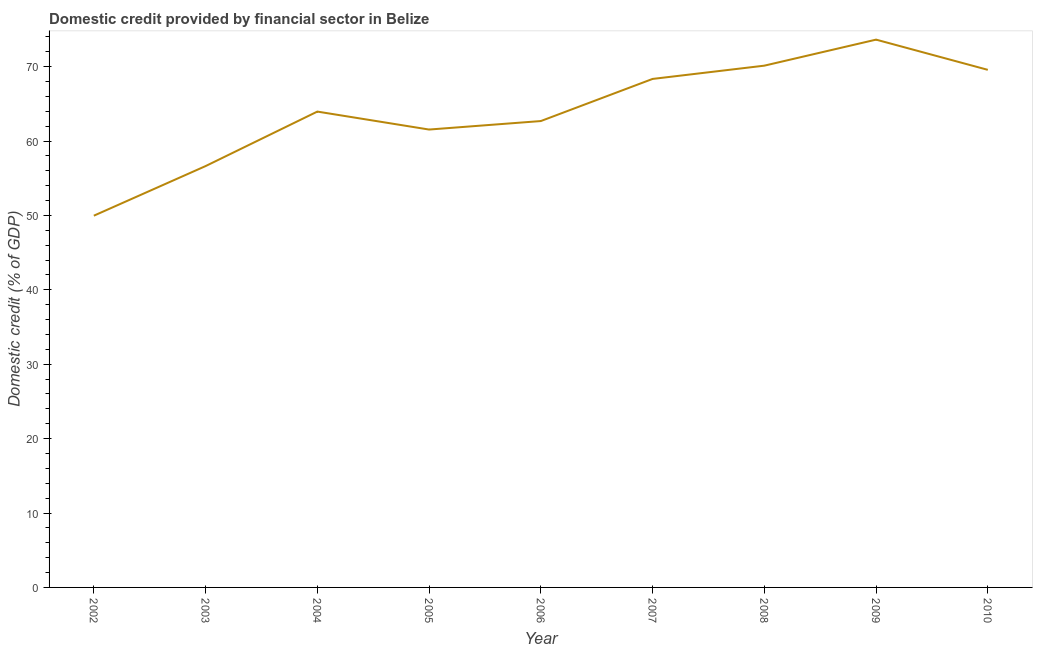What is the domestic credit provided by financial sector in 2002?
Your answer should be very brief. 49.97. Across all years, what is the maximum domestic credit provided by financial sector?
Give a very brief answer. 73.63. Across all years, what is the minimum domestic credit provided by financial sector?
Your answer should be compact. 49.97. In which year was the domestic credit provided by financial sector maximum?
Your answer should be compact. 2009. What is the sum of the domestic credit provided by financial sector?
Your answer should be very brief. 576.47. What is the difference between the domestic credit provided by financial sector in 2003 and 2009?
Give a very brief answer. -17. What is the average domestic credit provided by financial sector per year?
Your answer should be very brief. 64.05. What is the median domestic credit provided by financial sector?
Your answer should be compact. 63.96. Do a majority of the years between 2005 and 2002 (inclusive) have domestic credit provided by financial sector greater than 66 %?
Offer a very short reply. Yes. What is the ratio of the domestic credit provided by financial sector in 2006 to that in 2010?
Your answer should be compact. 0.9. What is the difference between the highest and the second highest domestic credit provided by financial sector?
Your response must be concise. 3.5. What is the difference between the highest and the lowest domestic credit provided by financial sector?
Make the answer very short. 23.67. How many years are there in the graph?
Provide a short and direct response. 9. What is the difference between two consecutive major ticks on the Y-axis?
Make the answer very short. 10. Does the graph contain any zero values?
Your answer should be compact. No. Does the graph contain grids?
Your response must be concise. No. What is the title of the graph?
Offer a terse response. Domestic credit provided by financial sector in Belize. What is the label or title of the Y-axis?
Offer a terse response. Domestic credit (% of GDP). What is the Domestic credit (% of GDP) in 2002?
Make the answer very short. 49.97. What is the Domestic credit (% of GDP) of 2003?
Provide a short and direct response. 56.63. What is the Domestic credit (% of GDP) of 2004?
Ensure brevity in your answer.  63.96. What is the Domestic credit (% of GDP) in 2005?
Ensure brevity in your answer.  61.55. What is the Domestic credit (% of GDP) in 2006?
Keep it short and to the point. 62.69. What is the Domestic credit (% of GDP) in 2007?
Ensure brevity in your answer.  68.35. What is the Domestic credit (% of GDP) of 2008?
Your answer should be very brief. 70.13. What is the Domestic credit (% of GDP) of 2009?
Give a very brief answer. 73.63. What is the Domestic credit (% of GDP) of 2010?
Your answer should be very brief. 69.57. What is the difference between the Domestic credit (% of GDP) in 2002 and 2003?
Ensure brevity in your answer.  -6.67. What is the difference between the Domestic credit (% of GDP) in 2002 and 2004?
Your answer should be compact. -13.99. What is the difference between the Domestic credit (% of GDP) in 2002 and 2005?
Your answer should be compact. -11.58. What is the difference between the Domestic credit (% of GDP) in 2002 and 2006?
Keep it short and to the point. -12.72. What is the difference between the Domestic credit (% of GDP) in 2002 and 2007?
Provide a short and direct response. -18.38. What is the difference between the Domestic credit (% of GDP) in 2002 and 2008?
Ensure brevity in your answer.  -20.17. What is the difference between the Domestic credit (% of GDP) in 2002 and 2009?
Your response must be concise. -23.67. What is the difference between the Domestic credit (% of GDP) in 2002 and 2010?
Make the answer very short. -19.6. What is the difference between the Domestic credit (% of GDP) in 2003 and 2004?
Your response must be concise. -7.32. What is the difference between the Domestic credit (% of GDP) in 2003 and 2005?
Make the answer very short. -4.91. What is the difference between the Domestic credit (% of GDP) in 2003 and 2006?
Offer a very short reply. -6.05. What is the difference between the Domestic credit (% of GDP) in 2003 and 2007?
Offer a very short reply. -11.71. What is the difference between the Domestic credit (% of GDP) in 2003 and 2008?
Provide a short and direct response. -13.5. What is the difference between the Domestic credit (% of GDP) in 2003 and 2009?
Ensure brevity in your answer.  -17. What is the difference between the Domestic credit (% of GDP) in 2003 and 2010?
Your response must be concise. -12.94. What is the difference between the Domestic credit (% of GDP) in 2004 and 2005?
Your answer should be very brief. 2.41. What is the difference between the Domestic credit (% of GDP) in 2004 and 2006?
Make the answer very short. 1.27. What is the difference between the Domestic credit (% of GDP) in 2004 and 2007?
Provide a short and direct response. -4.39. What is the difference between the Domestic credit (% of GDP) in 2004 and 2008?
Keep it short and to the point. -6.17. What is the difference between the Domestic credit (% of GDP) in 2004 and 2009?
Ensure brevity in your answer.  -9.67. What is the difference between the Domestic credit (% of GDP) in 2004 and 2010?
Your answer should be very brief. -5.61. What is the difference between the Domestic credit (% of GDP) in 2005 and 2006?
Offer a terse response. -1.14. What is the difference between the Domestic credit (% of GDP) in 2005 and 2007?
Offer a terse response. -6.8. What is the difference between the Domestic credit (% of GDP) in 2005 and 2008?
Ensure brevity in your answer.  -8.59. What is the difference between the Domestic credit (% of GDP) in 2005 and 2009?
Provide a short and direct response. -12.09. What is the difference between the Domestic credit (% of GDP) in 2005 and 2010?
Offer a terse response. -8.03. What is the difference between the Domestic credit (% of GDP) in 2006 and 2007?
Provide a succinct answer. -5.66. What is the difference between the Domestic credit (% of GDP) in 2006 and 2008?
Offer a very short reply. -7.45. What is the difference between the Domestic credit (% of GDP) in 2006 and 2009?
Your answer should be very brief. -10.94. What is the difference between the Domestic credit (% of GDP) in 2006 and 2010?
Your answer should be very brief. -6.88. What is the difference between the Domestic credit (% of GDP) in 2007 and 2008?
Your answer should be compact. -1.78. What is the difference between the Domestic credit (% of GDP) in 2007 and 2009?
Ensure brevity in your answer.  -5.28. What is the difference between the Domestic credit (% of GDP) in 2007 and 2010?
Make the answer very short. -1.22. What is the difference between the Domestic credit (% of GDP) in 2008 and 2009?
Your answer should be very brief. -3.5. What is the difference between the Domestic credit (% of GDP) in 2008 and 2010?
Offer a terse response. 0.56. What is the difference between the Domestic credit (% of GDP) in 2009 and 2010?
Give a very brief answer. 4.06. What is the ratio of the Domestic credit (% of GDP) in 2002 to that in 2003?
Your answer should be very brief. 0.88. What is the ratio of the Domestic credit (% of GDP) in 2002 to that in 2004?
Ensure brevity in your answer.  0.78. What is the ratio of the Domestic credit (% of GDP) in 2002 to that in 2005?
Keep it short and to the point. 0.81. What is the ratio of the Domestic credit (% of GDP) in 2002 to that in 2006?
Ensure brevity in your answer.  0.8. What is the ratio of the Domestic credit (% of GDP) in 2002 to that in 2007?
Make the answer very short. 0.73. What is the ratio of the Domestic credit (% of GDP) in 2002 to that in 2008?
Make the answer very short. 0.71. What is the ratio of the Domestic credit (% of GDP) in 2002 to that in 2009?
Your answer should be compact. 0.68. What is the ratio of the Domestic credit (% of GDP) in 2002 to that in 2010?
Offer a very short reply. 0.72. What is the ratio of the Domestic credit (% of GDP) in 2003 to that in 2004?
Keep it short and to the point. 0.89. What is the ratio of the Domestic credit (% of GDP) in 2003 to that in 2006?
Offer a terse response. 0.9. What is the ratio of the Domestic credit (% of GDP) in 2003 to that in 2007?
Your answer should be compact. 0.83. What is the ratio of the Domestic credit (% of GDP) in 2003 to that in 2008?
Your answer should be compact. 0.81. What is the ratio of the Domestic credit (% of GDP) in 2003 to that in 2009?
Provide a succinct answer. 0.77. What is the ratio of the Domestic credit (% of GDP) in 2003 to that in 2010?
Ensure brevity in your answer.  0.81. What is the ratio of the Domestic credit (% of GDP) in 2004 to that in 2005?
Provide a succinct answer. 1.04. What is the ratio of the Domestic credit (% of GDP) in 2004 to that in 2007?
Your response must be concise. 0.94. What is the ratio of the Domestic credit (% of GDP) in 2004 to that in 2008?
Offer a terse response. 0.91. What is the ratio of the Domestic credit (% of GDP) in 2004 to that in 2009?
Provide a succinct answer. 0.87. What is the ratio of the Domestic credit (% of GDP) in 2004 to that in 2010?
Your answer should be compact. 0.92. What is the ratio of the Domestic credit (% of GDP) in 2005 to that in 2008?
Your answer should be very brief. 0.88. What is the ratio of the Domestic credit (% of GDP) in 2005 to that in 2009?
Your response must be concise. 0.84. What is the ratio of the Domestic credit (% of GDP) in 2005 to that in 2010?
Your response must be concise. 0.89. What is the ratio of the Domestic credit (% of GDP) in 2006 to that in 2007?
Keep it short and to the point. 0.92. What is the ratio of the Domestic credit (% of GDP) in 2006 to that in 2008?
Provide a short and direct response. 0.89. What is the ratio of the Domestic credit (% of GDP) in 2006 to that in 2009?
Offer a terse response. 0.85. What is the ratio of the Domestic credit (% of GDP) in 2006 to that in 2010?
Offer a terse response. 0.9. What is the ratio of the Domestic credit (% of GDP) in 2007 to that in 2008?
Keep it short and to the point. 0.97. What is the ratio of the Domestic credit (% of GDP) in 2007 to that in 2009?
Your answer should be very brief. 0.93. What is the ratio of the Domestic credit (% of GDP) in 2007 to that in 2010?
Your answer should be very brief. 0.98. What is the ratio of the Domestic credit (% of GDP) in 2008 to that in 2009?
Make the answer very short. 0.95. What is the ratio of the Domestic credit (% of GDP) in 2009 to that in 2010?
Your answer should be compact. 1.06. 